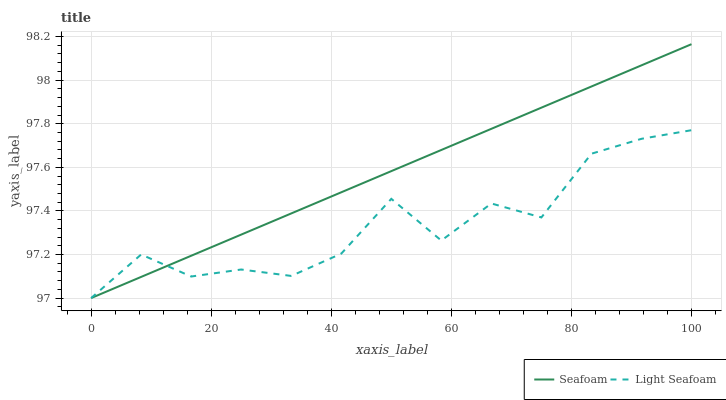Does Seafoam have the minimum area under the curve?
Answer yes or no. No. Is Seafoam the roughest?
Answer yes or no. No. 